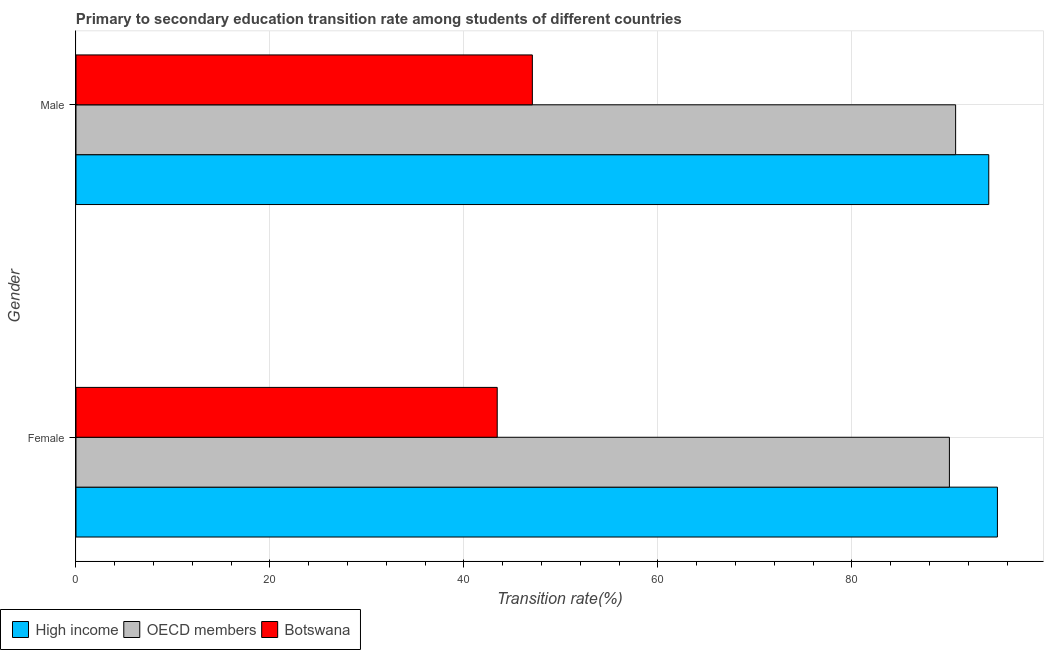How many groups of bars are there?
Offer a terse response. 2. Are the number of bars per tick equal to the number of legend labels?
Give a very brief answer. Yes. How many bars are there on the 2nd tick from the top?
Provide a short and direct response. 3. How many bars are there on the 2nd tick from the bottom?
Your answer should be compact. 3. What is the transition rate among female students in Botswana?
Give a very brief answer. 43.43. Across all countries, what is the maximum transition rate among male students?
Ensure brevity in your answer.  94.11. Across all countries, what is the minimum transition rate among female students?
Offer a very short reply. 43.43. In which country was the transition rate among male students maximum?
Provide a short and direct response. High income. In which country was the transition rate among female students minimum?
Give a very brief answer. Botswana. What is the total transition rate among male students in the graph?
Keep it short and to the point. 231.85. What is the difference between the transition rate among female students in OECD members and that in Botswana?
Provide a succinct answer. 46.62. What is the difference between the transition rate among male students in OECD members and the transition rate among female students in Botswana?
Provide a short and direct response. 47.26. What is the average transition rate among female students per country?
Offer a very short reply. 76.16. What is the difference between the transition rate among female students and transition rate among male students in Botswana?
Offer a very short reply. -3.62. What is the ratio of the transition rate among male students in Botswana to that in High income?
Provide a short and direct response. 0.5. Is the transition rate among male students in Botswana less than that in High income?
Provide a short and direct response. Yes. In how many countries, is the transition rate among female students greater than the average transition rate among female students taken over all countries?
Your answer should be compact. 2. What does the 1st bar from the top in Male represents?
Provide a succinct answer. Botswana. What does the 1st bar from the bottom in Female represents?
Your answer should be compact. High income. How many bars are there?
Your answer should be compact. 6. Are all the bars in the graph horizontal?
Your answer should be very brief. Yes. What is the difference between two consecutive major ticks on the X-axis?
Ensure brevity in your answer.  20. Does the graph contain any zero values?
Make the answer very short. No. How are the legend labels stacked?
Your answer should be compact. Horizontal. What is the title of the graph?
Make the answer very short. Primary to secondary education transition rate among students of different countries. Does "Kuwait" appear as one of the legend labels in the graph?
Make the answer very short. No. What is the label or title of the X-axis?
Your answer should be compact. Transition rate(%). What is the label or title of the Y-axis?
Keep it short and to the point. Gender. What is the Transition rate(%) in High income in Female?
Give a very brief answer. 95. What is the Transition rate(%) in OECD members in Female?
Provide a succinct answer. 90.05. What is the Transition rate(%) in Botswana in Female?
Ensure brevity in your answer.  43.43. What is the Transition rate(%) of High income in Male?
Offer a very short reply. 94.11. What is the Transition rate(%) in OECD members in Male?
Make the answer very short. 90.69. What is the Transition rate(%) in Botswana in Male?
Give a very brief answer. 47.05. Across all Gender, what is the maximum Transition rate(%) in High income?
Give a very brief answer. 95. Across all Gender, what is the maximum Transition rate(%) in OECD members?
Your answer should be compact. 90.69. Across all Gender, what is the maximum Transition rate(%) of Botswana?
Provide a succinct answer. 47.05. Across all Gender, what is the minimum Transition rate(%) in High income?
Make the answer very short. 94.11. Across all Gender, what is the minimum Transition rate(%) in OECD members?
Ensure brevity in your answer.  90.05. Across all Gender, what is the minimum Transition rate(%) of Botswana?
Your answer should be very brief. 43.43. What is the total Transition rate(%) in High income in the graph?
Your answer should be very brief. 189.1. What is the total Transition rate(%) in OECD members in the graph?
Offer a very short reply. 180.74. What is the total Transition rate(%) in Botswana in the graph?
Your answer should be very brief. 90.48. What is the difference between the Transition rate(%) of High income in Female and that in Male?
Make the answer very short. 0.89. What is the difference between the Transition rate(%) in OECD members in Female and that in Male?
Offer a terse response. -0.64. What is the difference between the Transition rate(%) in Botswana in Female and that in Male?
Provide a succinct answer. -3.62. What is the difference between the Transition rate(%) of High income in Female and the Transition rate(%) of OECD members in Male?
Provide a short and direct response. 4.31. What is the difference between the Transition rate(%) in High income in Female and the Transition rate(%) in Botswana in Male?
Provide a succinct answer. 47.95. What is the difference between the Transition rate(%) in OECD members in Female and the Transition rate(%) in Botswana in Male?
Provide a short and direct response. 43. What is the average Transition rate(%) of High income per Gender?
Your response must be concise. 94.55. What is the average Transition rate(%) of OECD members per Gender?
Offer a very short reply. 90.37. What is the average Transition rate(%) of Botswana per Gender?
Give a very brief answer. 45.24. What is the difference between the Transition rate(%) in High income and Transition rate(%) in OECD members in Female?
Ensure brevity in your answer.  4.95. What is the difference between the Transition rate(%) in High income and Transition rate(%) in Botswana in Female?
Provide a short and direct response. 51.57. What is the difference between the Transition rate(%) of OECD members and Transition rate(%) of Botswana in Female?
Make the answer very short. 46.62. What is the difference between the Transition rate(%) in High income and Transition rate(%) in OECD members in Male?
Your answer should be compact. 3.42. What is the difference between the Transition rate(%) in High income and Transition rate(%) in Botswana in Male?
Your response must be concise. 47.05. What is the difference between the Transition rate(%) in OECD members and Transition rate(%) in Botswana in Male?
Provide a succinct answer. 43.64. What is the ratio of the Transition rate(%) of High income in Female to that in Male?
Provide a succinct answer. 1.01. What is the ratio of the Transition rate(%) in Botswana in Female to that in Male?
Offer a terse response. 0.92. What is the difference between the highest and the second highest Transition rate(%) of High income?
Give a very brief answer. 0.89. What is the difference between the highest and the second highest Transition rate(%) of OECD members?
Give a very brief answer. 0.64. What is the difference between the highest and the second highest Transition rate(%) in Botswana?
Make the answer very short. 3.62. What is the difference between the highest and the lowest Transition rate(%) in High income?
Offer a very short reply. 0.89. What is the difference between the highest and the lowest Transition rate(%) of OECD members?
Give a very brief answer. 0.64. What is the difference between the highest and the lowest Transition rate(%) in Botswana?
Provide a succinct answer. 3.62. 